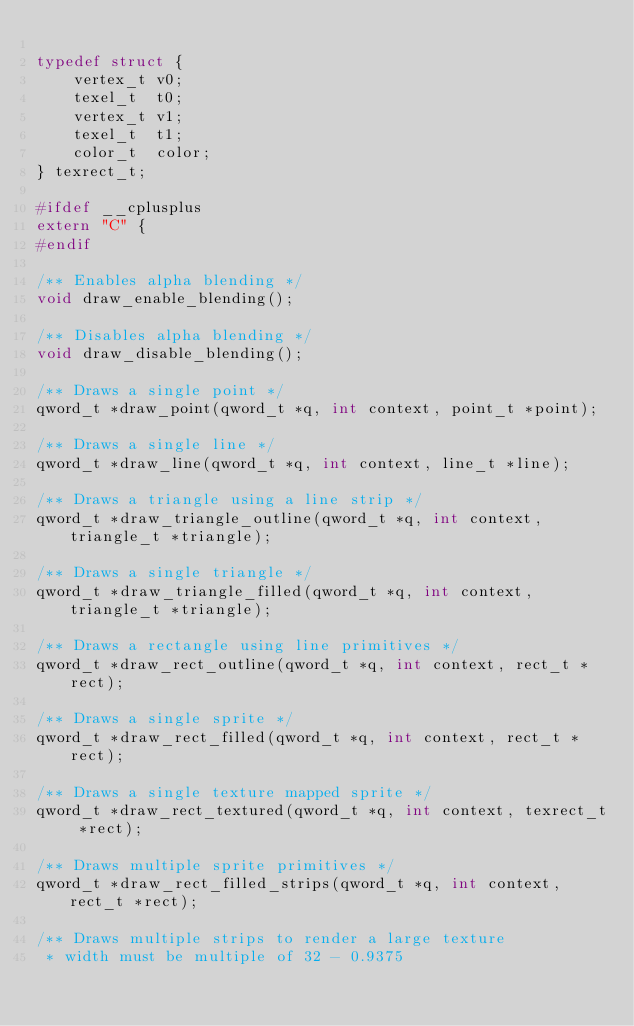<code> <loc_0><loc_0><loc_500><loc_500><_C_>
typedef struct {
	vertex_t v0;
	texel_t  t0;
	vertex_t v1;
	texel_t  t1;
	color_t  color;
} texrect_t;

#ifdef __cplusplus
extern "C" {
#endif

/** Enables alpha blending */
void draw_enable_blending();

/** Disables alpha blending */
void draw_disable_blending();

/** Draws a single point */
qword_t *draw_point(qword_t *q, int context, point_t *point);

/** Draws a single line */
qword_t *draw_line(qword_t *q, int context, line_t *line);

/** Draws a triangle using a line strip */
qword_t *draw_triangle_outline(qword_t *q, int context, triangle_t *triangle);

/** Draws a single triangle */
qword_t *draw_triangle_filled(qword_t *q, int context,triangle_t *triangle);

/** Draws a rectangle using line primitives */
qword_t *draw_rect_outline(qword_t *q, int context, rect_t *rect);

/** Draws a single sprite */
qword_t *draw_rect_filled(qword_t *q, int context, rect_t *rect);

/** Draws a single texture mapped sprite */
qword_t *draw_rect_textured(qword_t *q, int context, texrect_t *rect);

/** Draws multiple sprite primitives */
qword_t *draw_rect_filled_strips(qword_t *q, int context, rect_t *rect);

/** Draws multiple strips to render a large texture
 * width must be multiple of 32 - 0.9375</code> 